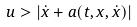Convert formula to latex. <formula><loc_0><loc_0><loc_500><loc_500>u > | \dot { x } + a ( t , x , \dot { x } ) |</formula> 